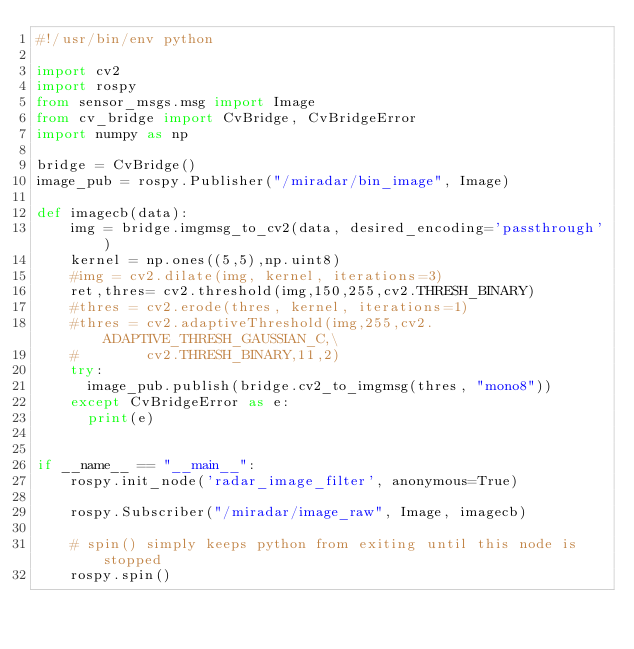Convert code to text. <code><loc_0><loc_0><loc_500><loc_500><_Python_>#!/usr/bin/env python

import cv2
import rospy
from sensor_msgs.msg import Image
from cv_bridge import CvBridge, CvBridgeError
import numpy as np

bridge = CvBridge()
image_pub = rospy.Publisher("/miradar/bin_image", Image)

def imagecb(data):
    img = bridge.imgmsg_to_cv2(data, desired_encoding='passthrough')
    kernel = np.ones((5,5),np.uint8)
    #img = cv2.dilate(img, kernel, iterations=3)
    ret,thres= cv2.threshold(img,150,255,cv2.THRESH_BINARY)
    #thres = cv2.erode(thres, kernel, iterations=1)
    #thres = cv2.adaptiveThreshold(img,255,cv2.ADAPTIVE_THRESH_GAUSSIAN_C,\
    #        cv2.THRESH_BINARY,11,2)
    try:
      image_pub.publish(bridge.cv2_to_imgmsg(thres, "mono8"))
    except CvBridgeError as e:
      print(e)


if __name__ == "__main__":
    rospy.init_node('radar_image_filter', anonymous=True)

    rospy.Subscriber("/miradar/image_raw", Image, imagecb)

    # spin() simply keeps python from exiting until this node is stopped
    rospy.spin()</code> 